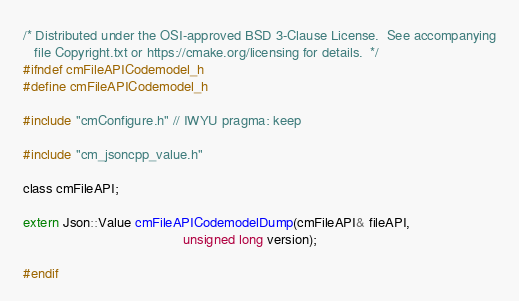<code> <loc_0><loc_0><loc_500><loc_500><_C_>/* Distributed under the OSI-approved BSD 3-Clause License.  See accompanying
   file Copyright.txt or https://cmake.org/licensing for details.  */
#ifndef cmFileAPICodemodel_h
#define cmFileAPICodemodel_h

#include "cmConfigure.h" // IWYU pragma: keep

#include "cm_jsoncpp_value.h"

class cmFileAPI;

extern Json::Value cmFileAPICodemodelDump(cmFileAPI& fileAPI,
                                          unsigned long version);

#endif
</code> 